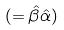Convert formula to latex. <formula><loc_0><loc_0><loc_500><loc_500>( = \hat { \beta } \hat { \alpha } )</formula> 